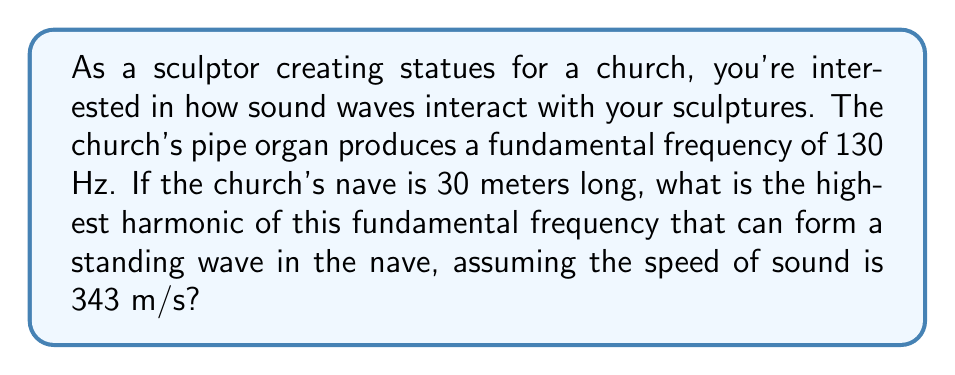Provide a solution to this math problem. To solve this problem, we need to follow these steps:

1) First, recall that the wavelength ($\lambda$) of a standing wave in a confined space is related to the length of the space (L) by:

   $$L = n\frac{\lambda}{2}$$

   where n is an integer representing the harmonic number.

2) We also know that the relationship between frequency (f), wavelength ($\lambda$), and speed of sound (v) is:

   $$v = f\lambda$$

3) For the fundamental frequency (f₀ = 130 Hz), we can find its wavelength:

   $$\lambda_0 = \frac{v}{f_0} = \frac{343 \text{ m/s}}{130 \text{ Hz}} \approx 2.64 \text{ m}$$

4) Now, for the nth harmonic, its frequency (f_n) is related to the fundamental frequency by:

   $$f_n = nf_0$$

5) Substituting this into the wave equation:

   $$v = nf_0\lambda_n$$

6) Rearranging for $\lambda_n$:

   $$\lambda_n = \frac{v}{nf_0} = \frac{\lambda_0}{n}$$

7) Now, we can set up our equation using the length of the nave:

   $$30 = n\frac{\lambda_n}{2} = n\frac{\lambda_0}{2n} = \frac{\lambda_0}{2}$$

8) Solving for n:

   $$n = \frac{60}{\lambda_0} = \frac{60}{2.64} \approx 22.73$$

9) Since n must be an integer, we round down to 22.

Therefore, the 22nd harmonic is the highest that can form a standing wave in the nave.
Answer: 22 